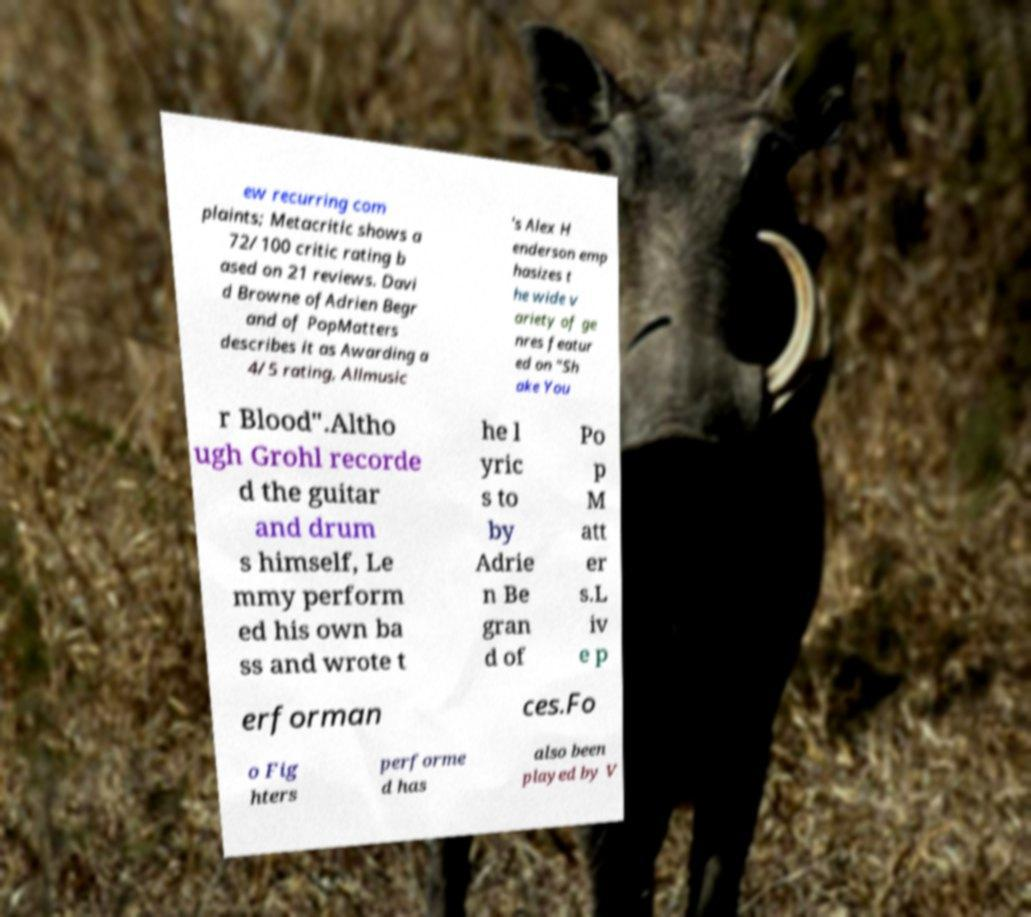There's text embedded in this image that I need extracted. Can you transcribe it verbatim? ew recurring com plaints; Metacritic shows a 72/100 critic rating b ased on 21 reviews. Davi d Browne ofAdrien Begr and of PopMatters describes it as Awarding a 4/5 rating, Allmusic 's Alex H enderson emp hasizes t he wide v ariety of ge nres featur ed on "Sh ake You r Blood".Altho ugh Grohl recorde d the guitar and drum s himself, Le mmy perform ed his own ba ss and wrote t he l yric s to by Adrie n Be gran d of Po p M att er s.L iv e p erforman ces.Fo o Fig hters performe d has also been played by V 